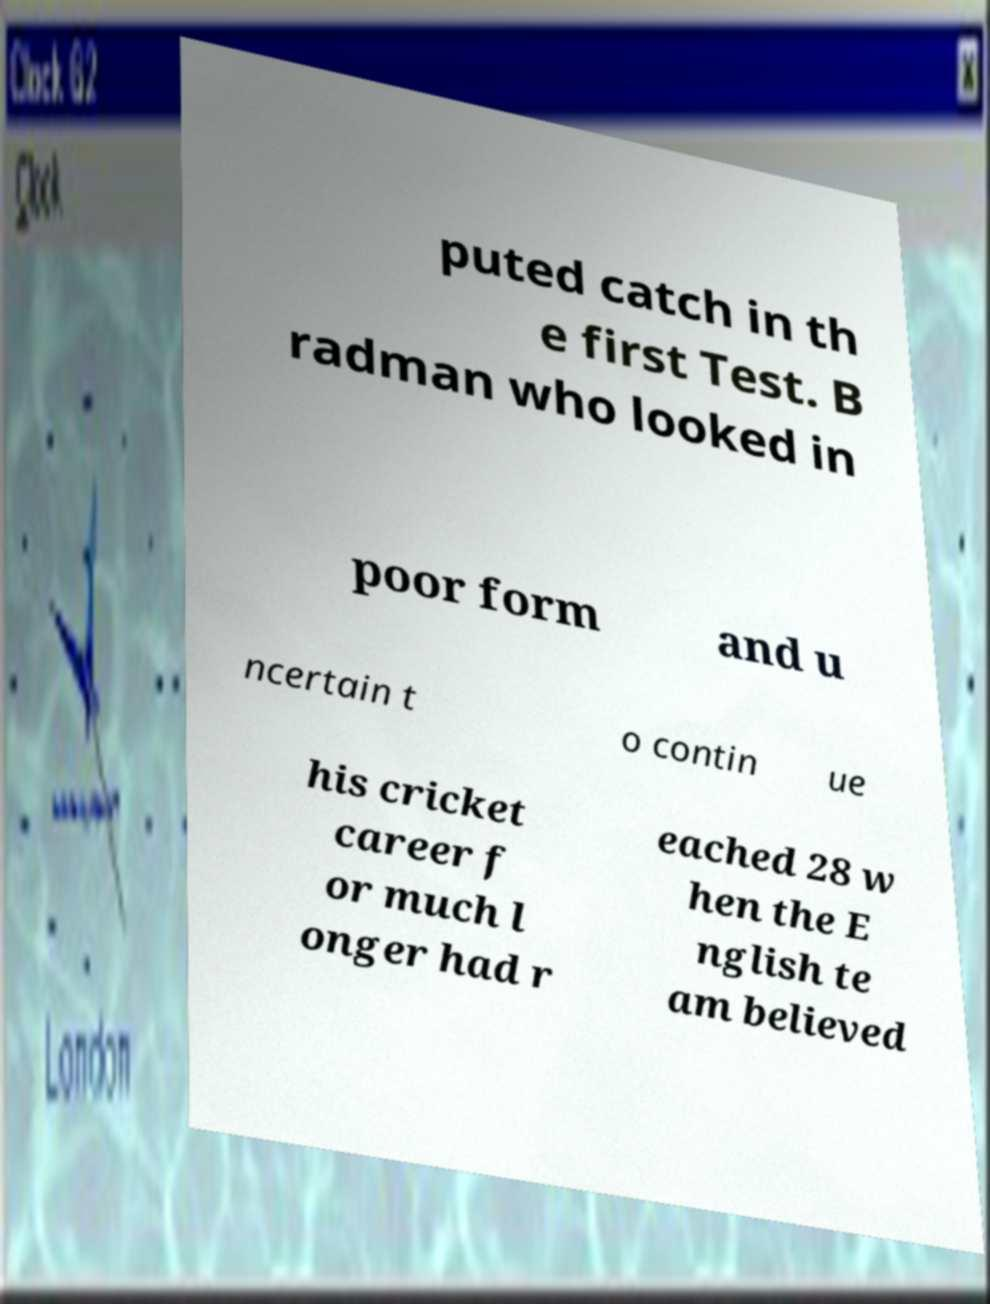Can you read and provide the text displayed in the image?This photo seems to have some interesting text. Can you extract and type it out for me? puted catch in th e first Test. B radman who looked in poor form and u ncertain t o contin ue his cricket career f or much l onger had r eached 28 w hen the E nglish te am believed 